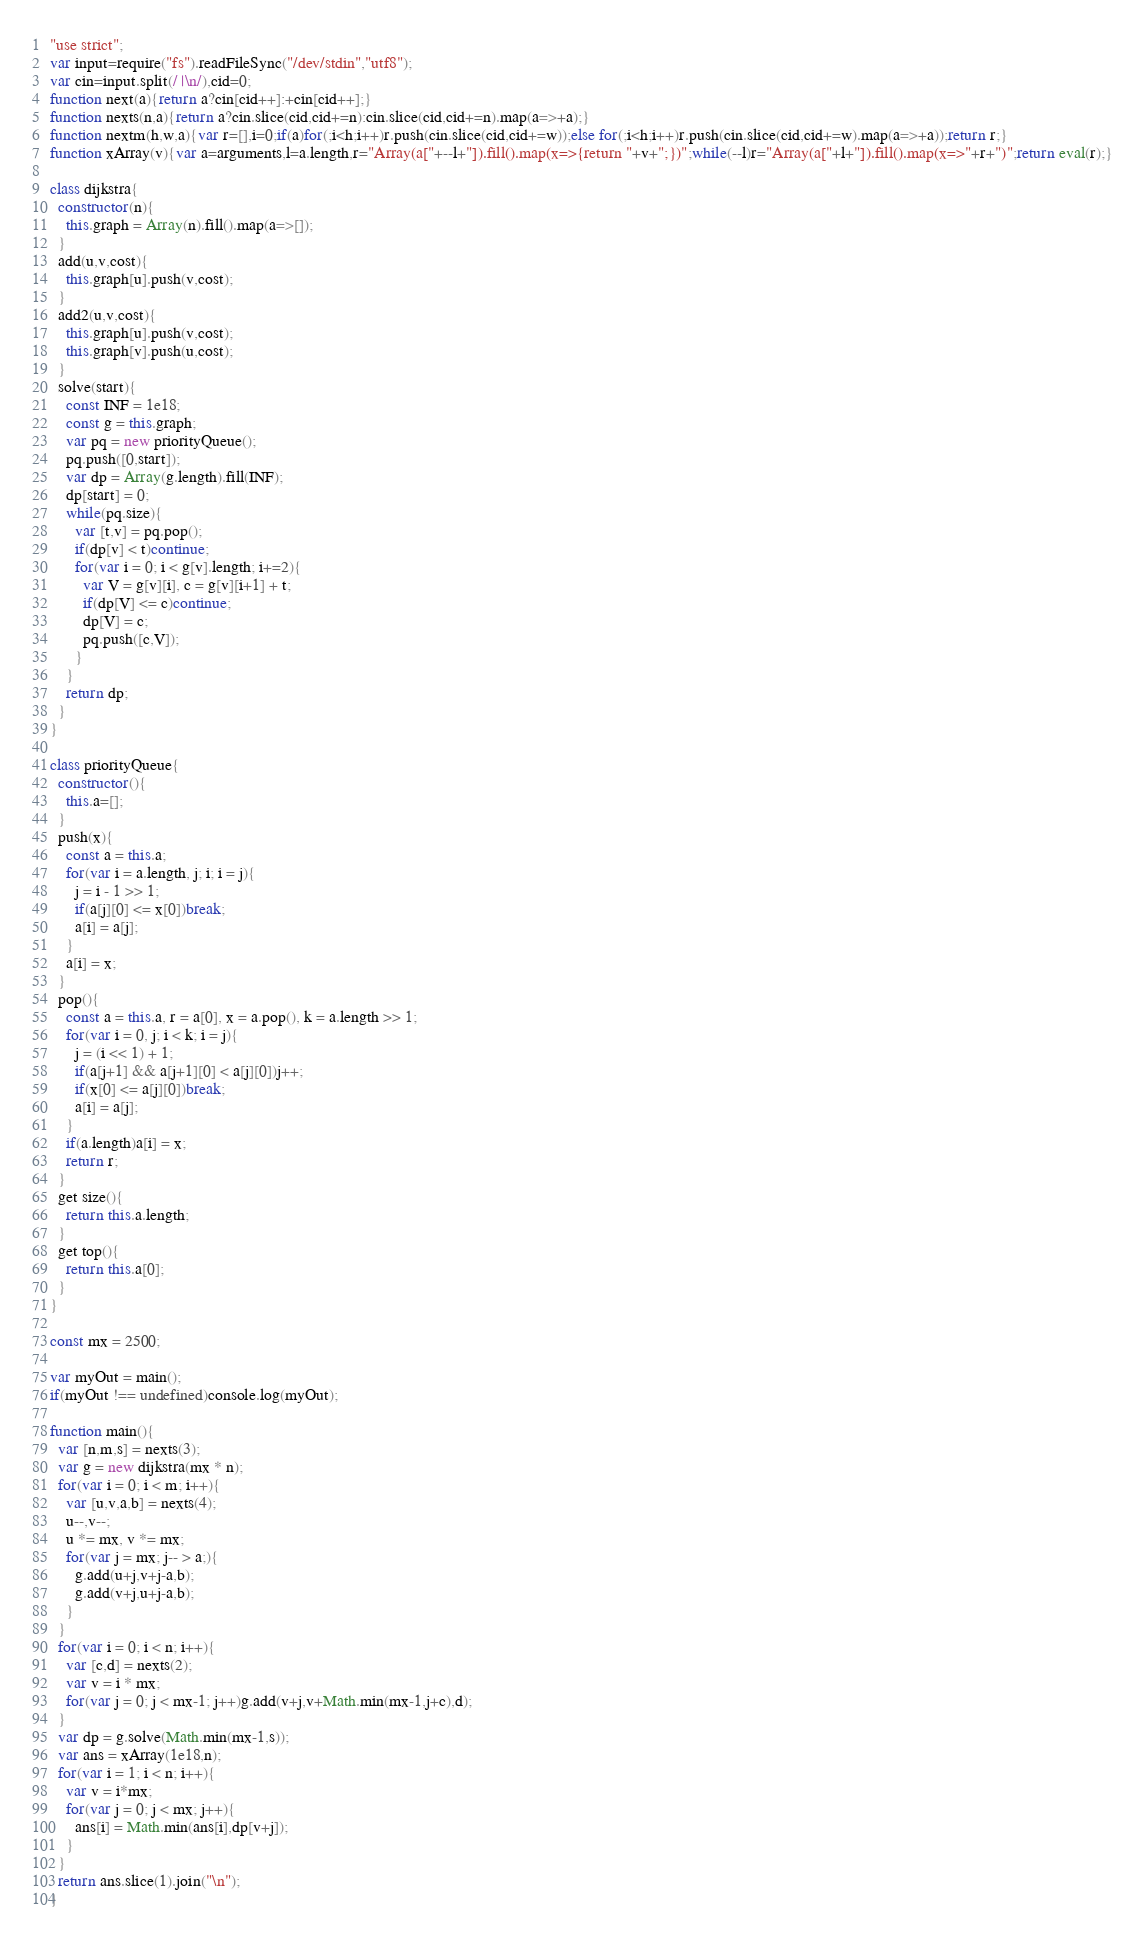Convert code to text. <code><loc_0><loc_0><loc_500><loc_500><_JavaScript_>"use strict";
var input=require("fs").readFileSync("/dev/stdin","utf8");
var cin=input.split(/ |\n/),cid=0;
function next(a){return a?cin[cid++]:+cin[cid++];}
function nexts(n,a){return a?cin.slice(cid,cid+=n):cin.slice(cid,cid+=n).map(a=>+a);}
function nextm(h,w,a){var r=[],i=0;if(a)for(;i<h;i++)r.push(cin.slice(cid,cid+=w));else for(;i<h;i++)r.push(cin.slice(cid,cid+=w).map(a=>+a));return r;}
function xArray(v){var a=arguments,l=a.length,r="Array(a["+--l+"]).fill().map(x=>{return "+v+";})";while(--l)r="Array(a["+l+"]).fill().map(x=>"+r+")";return eval(r);}

class dijkstra{
  constructor(n){
    this.graph = Array(n).fill().map(a=>[]);
  }
  add(u,v,cost){
    this.graph[u].push(v,cost);
  }
  add2(u,v,cost){
    this.graph[u].push(v,cost);
    this.graph[v].push(u,cost);
  }
  solve(start){
    const INF = 1e18;
    const g = this.graph;
    var pq = new priorityQueue();
    pq.push([0,start]);
    var dp = Array(g.length).fill(INF);
    dp[start] = 0;
    while(pq.size){
      var [t,v] = pq.pop();
      if(dp[v] < t)continue;
      for(var i = 0; i < g[v].length; i+=2){
        var V = g[v][i], c = g[v][i+1] + t;
        if(dp[V] <= c)continue;
        dp[V] = c;
        pq.push([c,V]);
      }
    }
    return dp;
  }
}

class priorityQueue{
  constructor(){
    this.a=[];
  }
  push(x){
    const a = this.a;
    for(var i = a.length, j; i; i = j){
      j = i - 1 >> 1;
      if(a[j][0] <= x[0])break;
      a[i] = a[j];
    }
    a[i] = x;
  }
  pop(){
    const a = this.a, r = a[0], x = a.pop(), k = a.length >> 1;
    for(var i = 0, j; i < k; i = j){
      j = (i << 1) + 1;
      if(a[j+1] && a[j+1][0] < a[j][0])j++;
      if(x[0] <= a[j][0])break;
      a[i] = a[j];
    }
    if(a.length)a[i] = x;
    return r;
  }
  get size(){
    return this.a.length;
  }
  get top(){
    return this.a[0];
  }
}

const mx = 2500;

var myOut = main();
if(myOut !== undefined)console.log(myOut);

function main(){
  var [n,m,s] = nexts(3);
  var g = new dijkstra(mx * n);
  for(var i = 0; i < m; i++){
    var [u,v,a,b] = nexts(4);
    u--,v--;
    u *= mx, v *= mx;
    for(var j = mx; j-- > a;){
      g.add(u+j,v+j-a,b);
      g.add(v+j,u+j-a,b);
    }
  }
  for(var i = 0; i < n; i++){
    var [c,d] = nexts(2);
    var v = i * mx;
    for(var j = 0; j < mx-1; j++)g.add(v+j,v+Math.min(mx-1,j+c),d);
  }
  var dp = g.solve(Math.min(mx-1,s));
  var ans = xArray(1e18,n);
  for(var i = 1; i < n; i++){
    var v = i*mx;
    for(var j = 0; j < mx; j++){
      ans[i] = Math.min(ans[i],dp[v+j]);
    }
  }
  return ans.slice(1).join("\n");
}</code> 